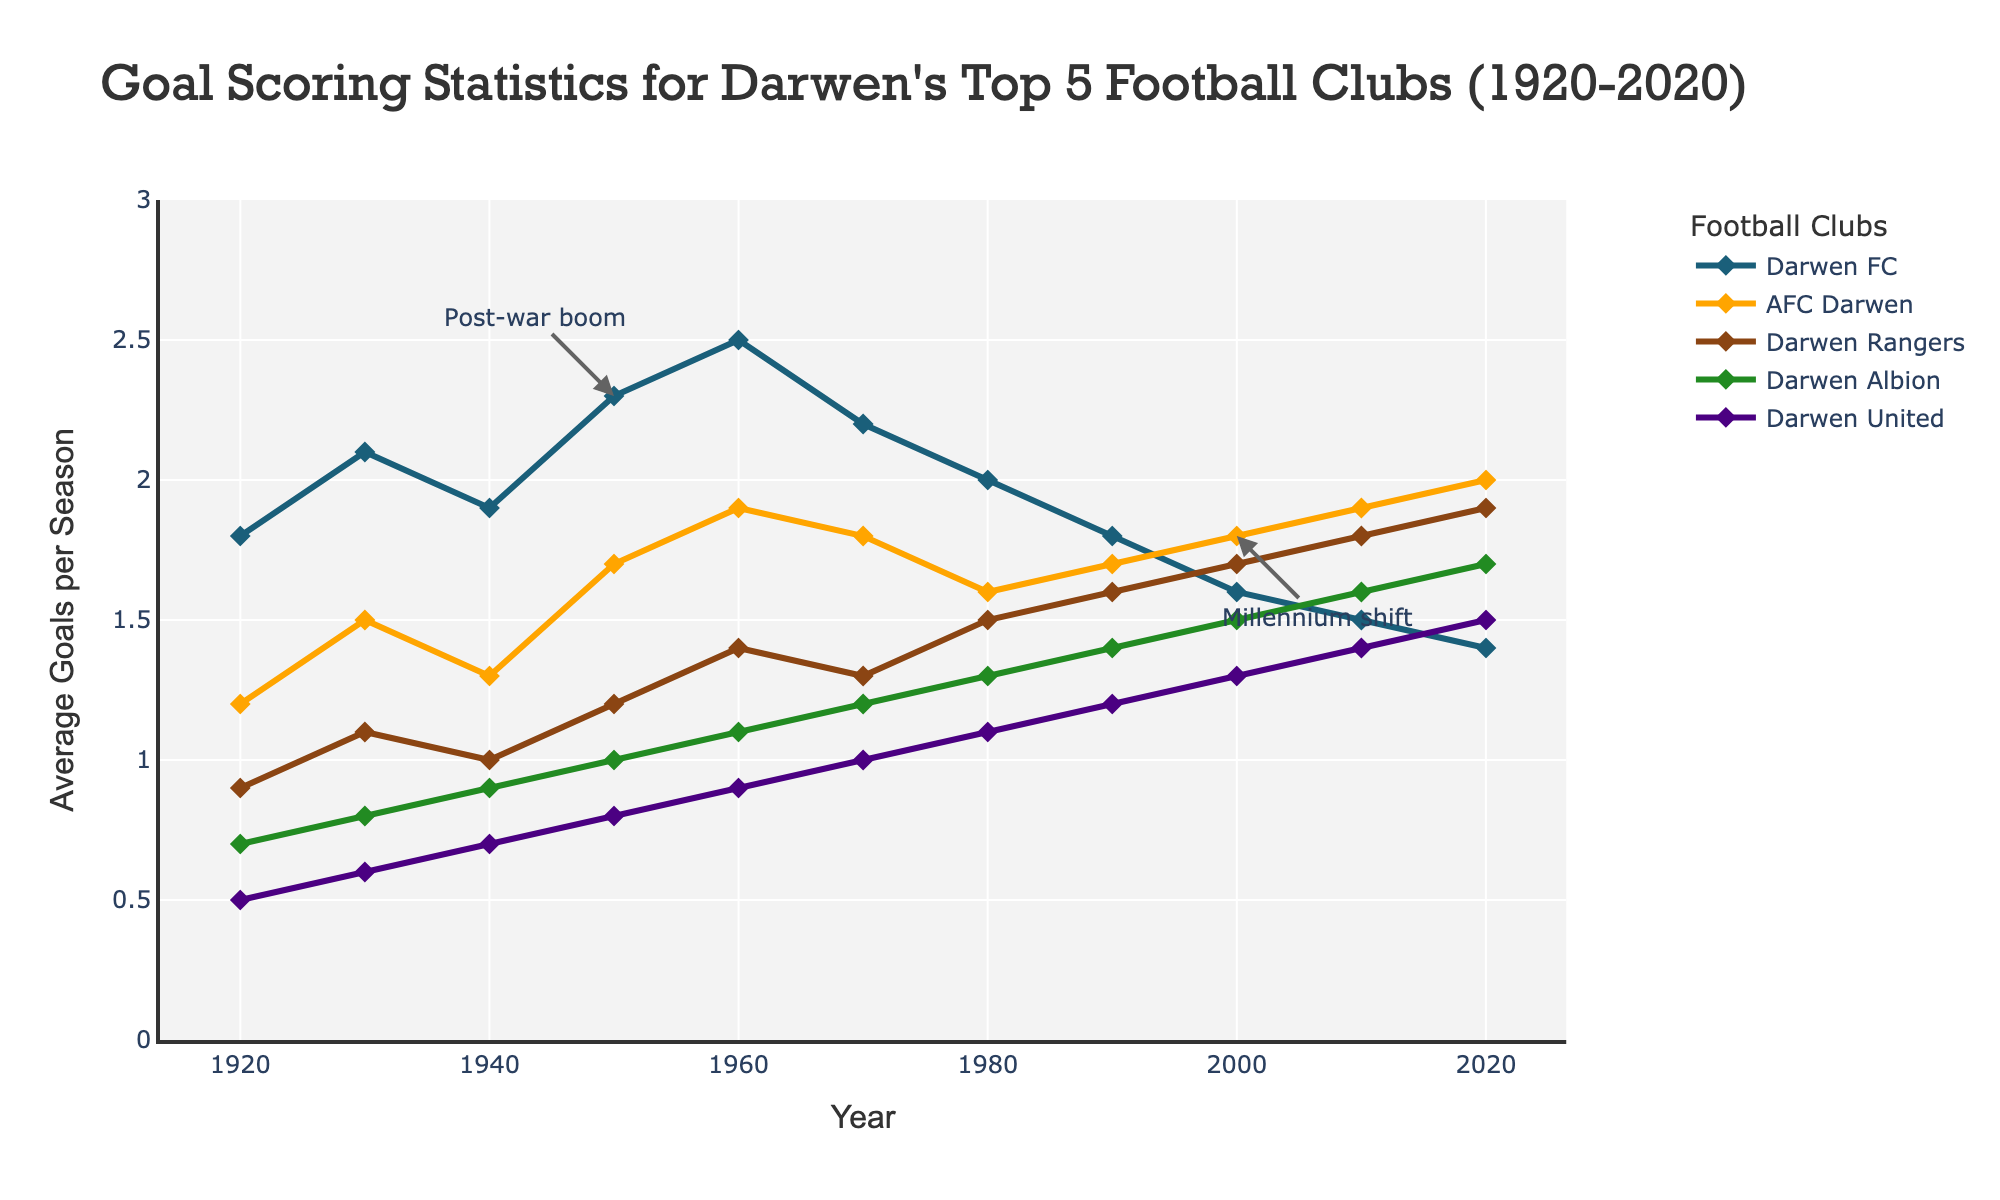Which club had the highest average goals per season in 1920? By looking at the data points for the year 1920, we can see that Darwen FC had the highest average goals per season at 1.8.
Answer: Darwen FC How did the average goals per season for Darwen FC change from 1950 to 2020? Darwen FC's average goals per season decreased from 2.3 in 1950 to 1.4 in 2020.
Answer: Decreased Comparing AFC Darwen and Darwen United, which club had a higher average goals per season in 2020 and by how much? In 2020, AFC Darwen had an average of 2.0 goals per season, while Darwen United had 1.5. The difference is 2.0 - 1.5 = 0.5.
Answer: AFC Darwen by 0.5 Which two clubs had the closest average goals per season in 1970? Checking the averages for 1970, Darwen Rangers and Darwen Albion had averages of 1.3 and 1.2 respectively, making them the closest.
Answer: Darwen Rangers and Darwen Albion What was the overall trend in the average goals per season for Darwen Albion from 1920 to 2020? The trend shows that Darwen Albion's average goals per season generally increased from 0.7 in 1920 up to 1.7 in 2020.
Answer: Increased Which club showed the least variation in their average goals per season over the entire period? By observing the fluctuating trends of each club, Darwen United appears to have the least variation, consistently increasing or maintaining a steady rise.
Answer: Darwen United How many times did Darwen FC's average goals per season surpass 2 goals in the periods shown? Darwen FC surpassed 2 goals per season in 1930, 1950, and 1960. That makes it a total of 3 times.
Answer: 3 times In which decade did AFC Darwen first overtake Darwen FC in average goals per season? AFC Darwen first overtook Darwen FC in average goals per season in the 1990s.
Answer: 1990s What is the difference in average goals per season between the club with the highest and the club with the lowest average in 1960? In 1960, Darwen FC had the highest average at 2.5, and Darwen United had the lowest at 0.9. The difference is 2.5 - 0.9 = 1.6.
Answer: 1.6 During which period did Darwen Rangers experience the biggest increase in their average goals per season? Darwen Rangers experienced the biggest increase in their average goals per season between 1930 and 1940, going from 1.1 to 1.4.
Answer: 1930-1940 